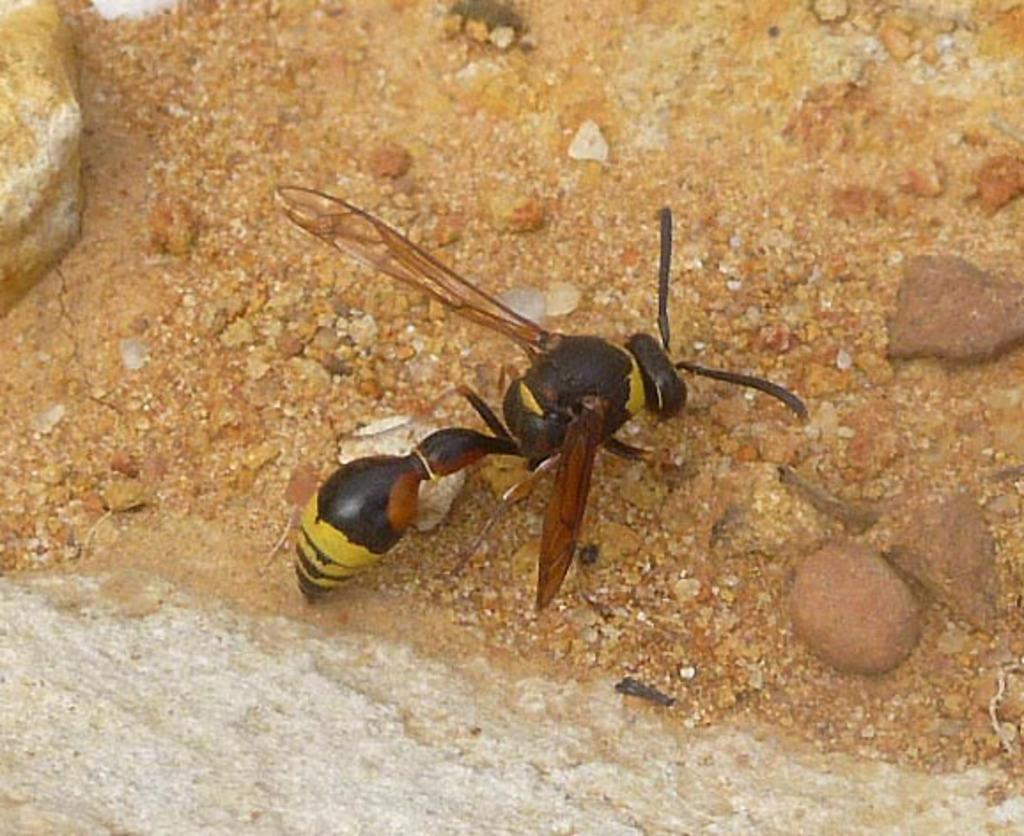What type of creature can be seen in the image? There is an insect in the image. Where is the insect located in the image? The insect is on the ground. What can be seen in the background of the image? There are stones visible in the background of the image. How many representatives are present in the image? There is no reference to representatives in the image; it features an insect on the ground and stones in the background. Is the insect located near the sea in the image? There is no sea present in the image; it features an insect on the ground and stones in the background. 